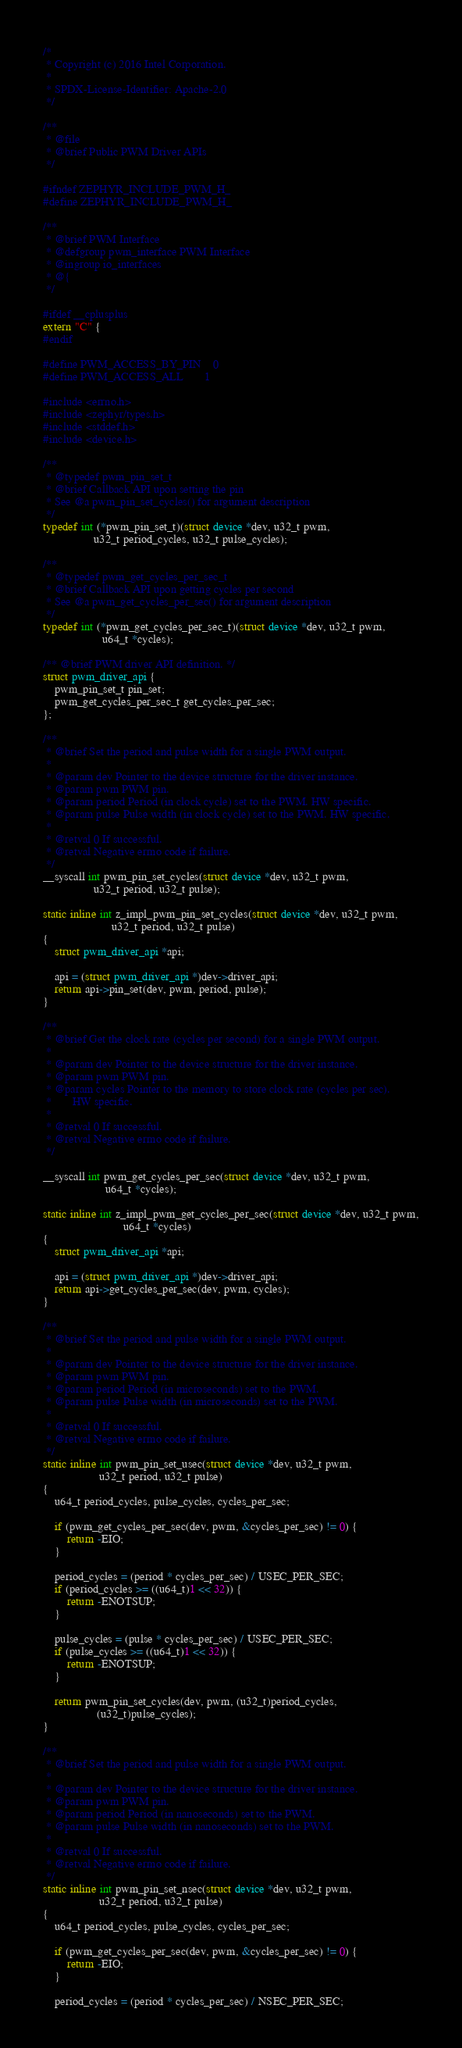Convert code to text. <code><loc_0><loc_0><loc_500><loc_500><_C_>/*
 * Copyright (c) 2016 Intel Corporation.
 *
 * SPDX-License-Identifier: Apache-2.0
 */

/**
 * @file
 * @brief Public PWM Driver APIs
 */

#ifndef ZEPHYR_INCLUDE_PWM_H_
#define ZEPHYR_INCLUDE_PWM_H_

/**
 * @brief PWM Interface
 * @defgroup pwm_interface PWM Interface
 * @ingroup io_interfaces
 * @{
 */

#ifdef __cplusplus
extern "C" {
#endif

#define PWM_ACCESS_BY_PIN	0
#define PWM_ACCESS_ALL		1

#include <errno.h>
#include <zephyr/types.h>
#include <stddef.h>
#include <device.h>

/**
 * @typedef pwm_pin_set_t
 * @brief Callback API upon setting the pin
 * See @a pwm_pin_set_cycles() for argument description
 */
typedef int (*pwm_pin_set_t)(struct device *dev, u32_t pwm,
			     u32_t period_cycles, u32_t pulse_cycles);

/**
 * @typedef pwm_get_cycles_per_sec_t
 * @brief Callback API upon getting cycles per second
 * See @a pwm_get_cycles_per_sec() for argument description
 */
typedef int (*pwm_get_cycles_per_sec_t)(struct device *dev, u32_t pwm,
					u64_t *cycles);

/** @brief PWM driver API definition. */
struct pwm_driver_api {
	pwm_pin_set_t pin_set;
	pwm_get_cycles_per_sec_t get_cycles_per_sec;
};

/**
 * @brief Set the period and pulse width for a single PWM output.
 *
 * @param dev Pointer to the device structure for the driver instance.
 * @param pwm PWM pin.
 * @param period Period (in clock cycle) set to the PWM. HW specific.
 * @param pulse Pulse width (in clock cycle) set to the PWM. HW specific.
 *
 * @retval 0 If successful.
 * @retval Negative errno code if failure.
 */
__syscall int pwm_pin_set_cycles(struct device *dev, u32_t pwm,
				 u32_t period, u32_t pulse);

static inline int z_impl_pwm_pin_set_cycles(struct device *dev, u32_t pwm,
					   u32_t period, u32_t pulse)
{
	struct pwm_driver_api *api;

	api = (struct pwm_driver_api *)dev->driver_api;
	return api->pin_set(dev, pwm, period, pulse);
}

/**
 * @brief Get the clock rate (cycles per second) for a single PWM output.
 *
 * @param dev Pointer to the device structure for the driver instance.
 * @param pwm PWM pin.
 * @param cycles Pointer to the memory to store clock rate (cycles per sec).
 *		 HW specific.
 *
 * @retval 0 If successful.
 * @retval Negative errno code if failure.
 */

__syscall int pwm_get_cycles_per_sec(struct device *dev, u32_t pwm,
				     u64_t *cycles);

static inline int z_impl_pwm_get_cycles_per_sec(struct device *dev, u32_t pwm,
					       u64_t *cycles)
{
	struct pwm_driver_api *api;

	api = (struct pwm_driver_api *)dev->driver_api;
	return api->get_cycles_per_sec(dev, pwm, cycles);
}

/**
 * @brief Set the period and pulse width for a single PWM output.
 *
 * @param dev Pointer to the device structure for the driver instance.
 * @param pwm PWM pin.
 * @param period Period (in microseconds) set to the PWM.
 * @param pulse Pulse width (in microseconds) set to the PWM.
 *
 * @retval 0 If successful.
 * @retval Negative errno code if failure.
 */
static inline int pwm_pin_set_usec(struct device *dev, u32_t pwm,
				   u32_t period, u32_t pulse)
{
	u64_t period_cycles, pulse_cycles, cycles_per_sec;

	if (pwm_get_cycles_per_sec(dev, pwm, &cycles_per_sec) != 0) {
		return -EIO;
	}

	period_cycles = (period * cycles_per_sec) / USEC_PER_SEC;
	if (period_cycles >= ((u64_t)1 << 32)) {
		return -ENOTSUP;
	}

	pulse_cycles = (pulse * cycles_per_sec) / USEC_PER_SEC;
	if (pulse_cycles >= ((u64_t)1 << 32)) {
		return -ENOTSUP;
	}

	return pwm_pin_set_cycles(dev, pwm, (u32_t)period_cycles,
				  (u32_t)pulse_cycles);
}

/**
 * @brief Set the period and pulse width for a single PWM output.
 *
 * @param dev Pointer to the device structure for the driver instance.
 * @param pwm PWM pin.
 * @param period Period (in nanoseconds) set to the PWM.
 * @param pulse Pulse width (in nanoseconds) set to the PWM.
 *
 * @retval 0 If successful.
 * @retval Negative errno code if failure.
 */
static inline int pwm_pin_set_nsec(struct device *dev, u32_t pwm,
				   u32_t period, u32_t pulse)
{
	u64_t period_cycles, pulse_cycles, cycles_per_sec;

	if (pwm_get_cycles_per_sec(dev, pwm, &cycles_per_sec) != 0) {
		return -EIO;
	}

	period_cycles = (period * cycles_per_sec) / NSEC_PER_SEC;</code> 